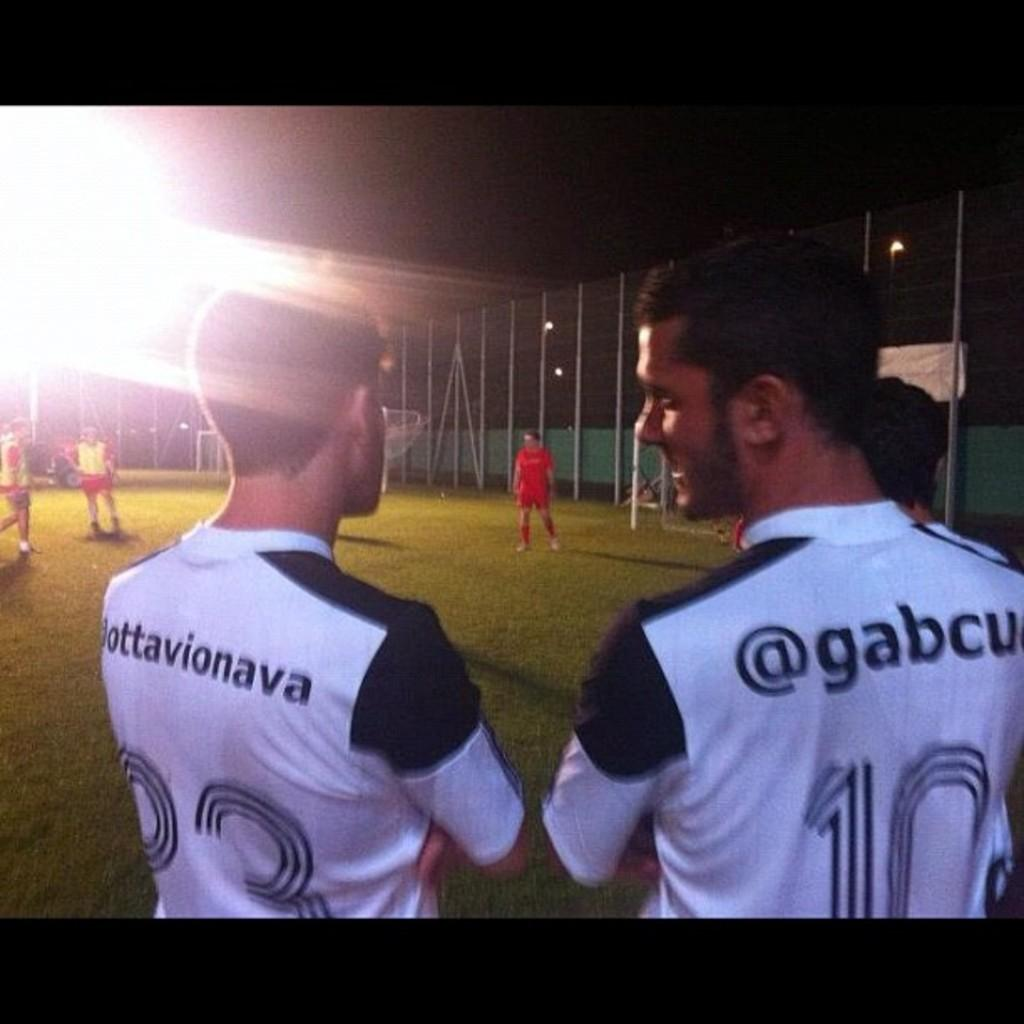<image>
Summarize the visual content of the image. two men stand next to eachother wearing uniform numbers 33 and 10 